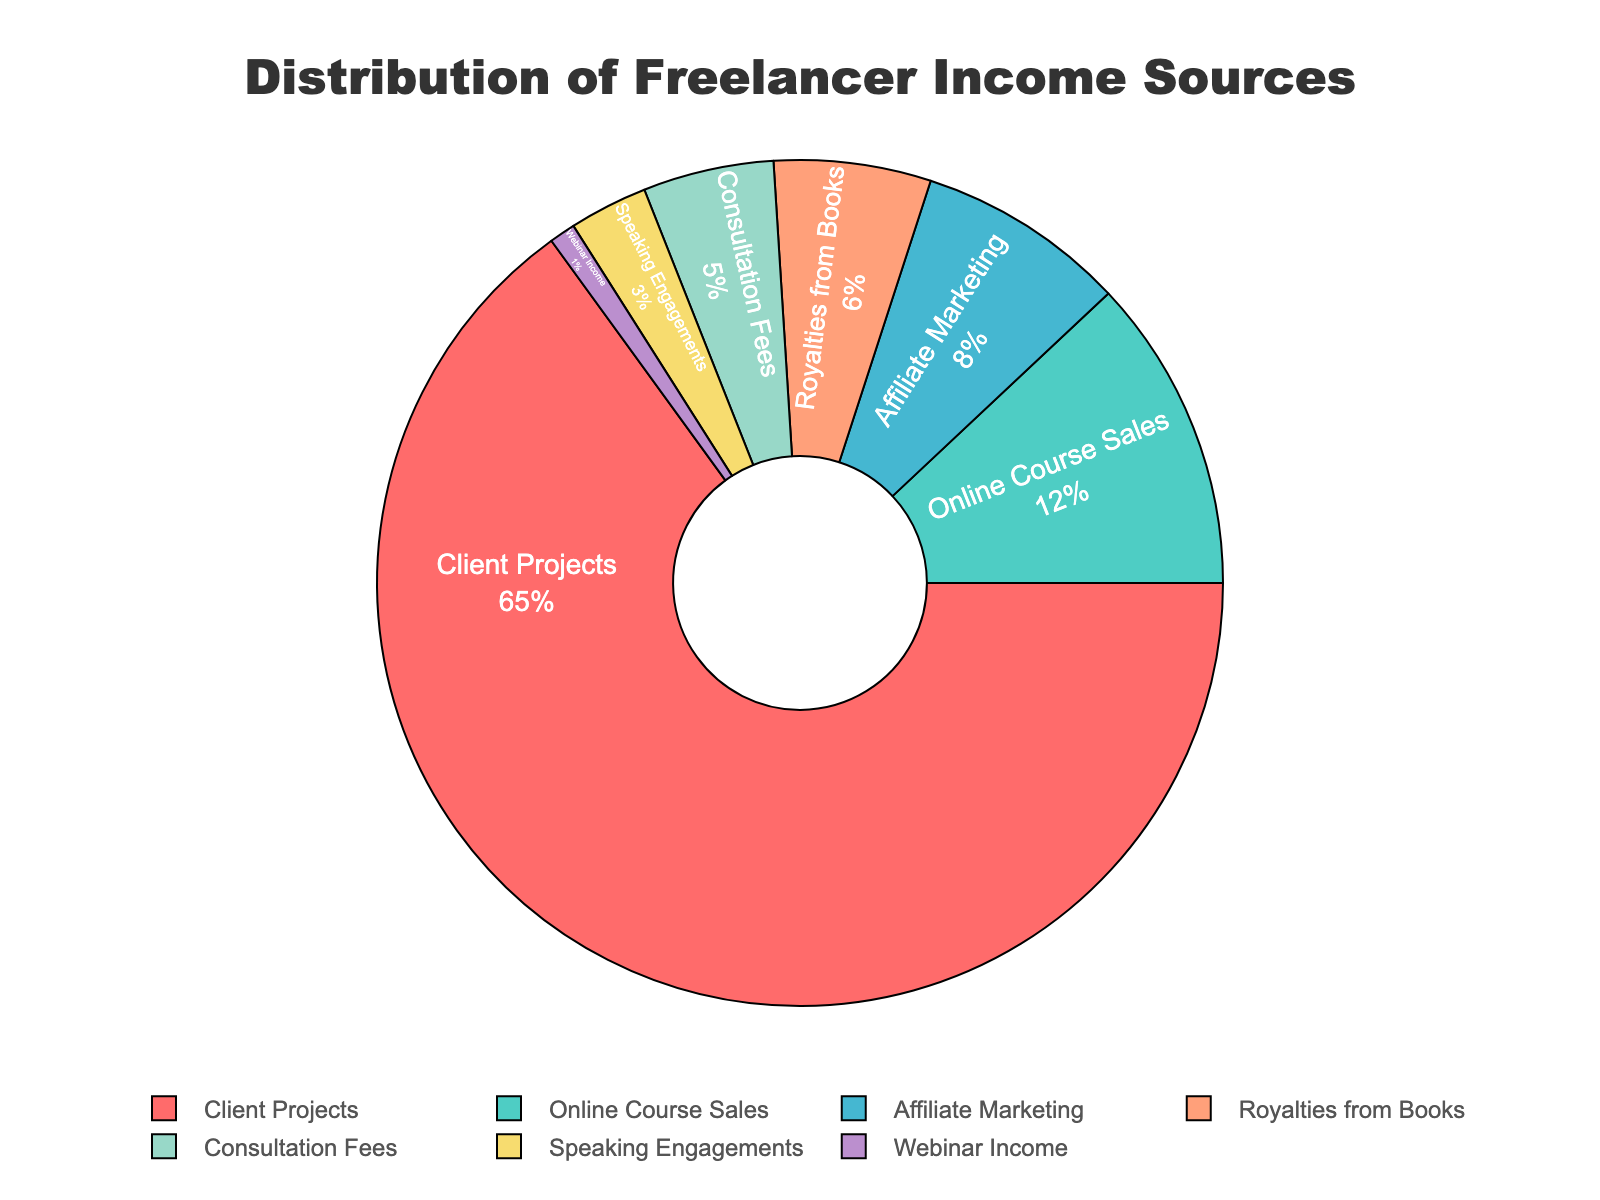What percentage of the freelancer's income comes from client projects? Referring to the figure, client projects have a segment labeled with the percentage inside it. The percentage shown in the client projects segment is 65%.
Answer: 65% Which income source contributes the least to the freelancer's income? By examining the smallest segment in the pie chart, we see that the segment labeled "Webinar Income" has the smallest percentage of 1%.
Answer: Webinar Income How much more does the freelancer earn from client projects compared to royalties from books? Referring to the percentages in the figure, client projects account for 65% while royalties from books account for 6%. The difference is calculated as 65% - 6% = 59%.
Answer: 59% What's the combined percentage of income from consultation fees and speaking engagements? The segment for consultation fees is labeled as 5% and the segment for speaking engagements is labeled as 3%. Adding them together gives 5% + 3% = 8%.
Answer: 8% Are online course sales more significant than affiliate marketing? By how much? The percentage for online course sales in the figure is 12% and for affiliate marketing is 8%. The difference is calculated as 12% - 8% = 4%.
Answer: Yes, by 4% What percentage of the freelancer's income comes from passive sources like royalties from books and affiliate marketing combined? The segment for royalties from books is 6% and affiliate marketing is 8%. Adding them together gives 6% + 8% = 14%.
Answer: 14% Among consultation fees and webinar income, which one contributes more to the freelancer's income? According to the figure, consultation fees account for 5% of the income while webinar income accounts for 1%. Therefore, consultation fees contribute more.
Answer: Consultation Fees If the freelancer wants to double the income from speaking engagements, what percentage would it represent? The current percentage for speaking engagements is 3%. Doubling this would be 3% * 2 = 6%.
Answer: 6% Is the income from client projects greater than the total income from online course sales, affiliate marketing, and royalties from books combined? Client projects account for 65%. The combined total of online course sales (12%), affiliate marketing (8%), and royalties from books (6%) is 12% + 8% + 6% = 26%. Since 65% > 26%, client projects generate more income.
Answer: Yes By how much do client projects exceed the combined percentage of all other income sources? Add up the percentages of all other income sources: online course sales (12%), affiliate marketing (8%), royalties from books (6%), consultation fees (5%), speaking engagements (3%), and webinar income (1%). The total is 12% + 8% + 6% + 5% + 3% + 1% = 35%. Client projects contribute 65%, and the difference is 65% - 35% = 30%.
Answer: 30% 